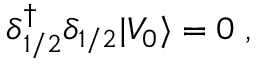Convert formula to latex. <formula><loc_0><loc_0><loc_500><loc_500>\delta { ^ { \dagger } _ { 1 / 2 } } \delta _ { 1 / 2 } | V _ { 0 } \rangle = 0 \, ,</formula> 